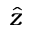Convert formula to latex. <formula><loc_0><loc_0><loc_500><loc_500>\hat { z }</formula> 